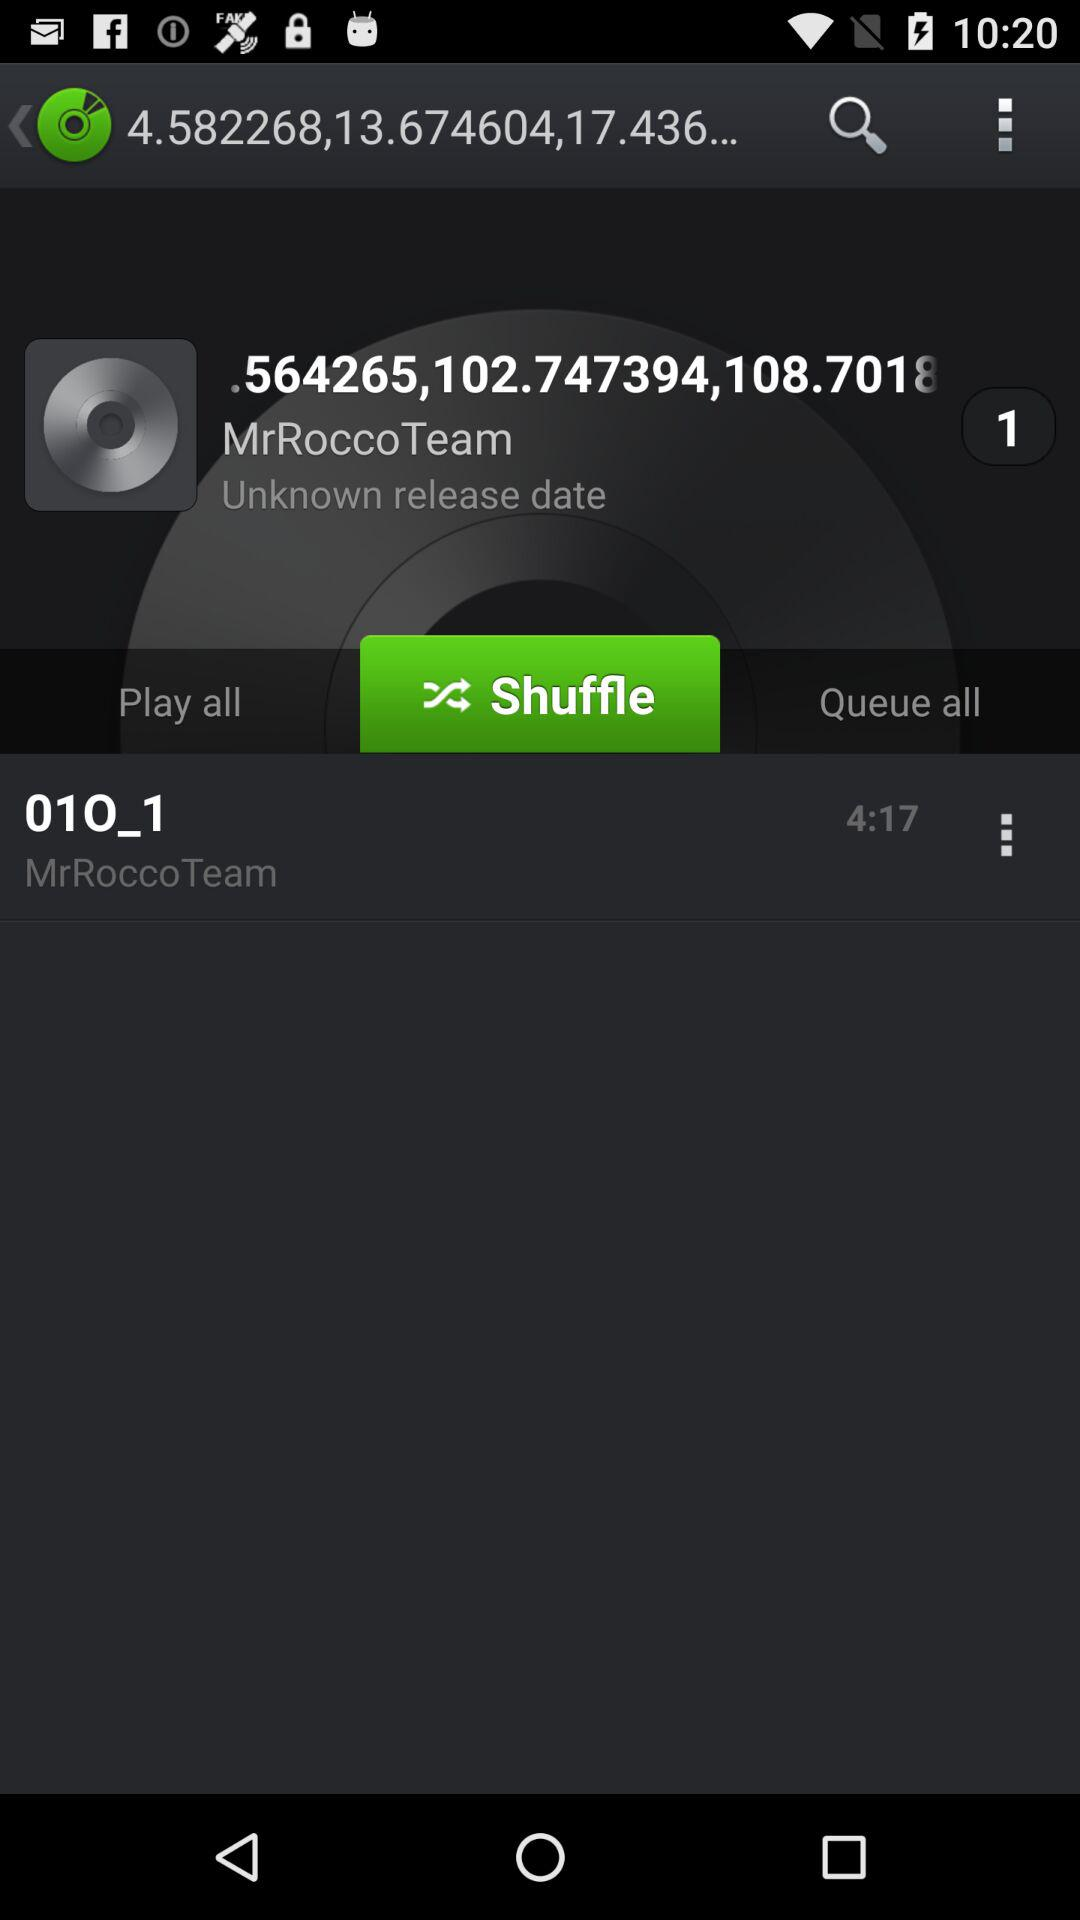What is the release date?
When the provided information is insufficient, respond with <no answer>. <no answer> 